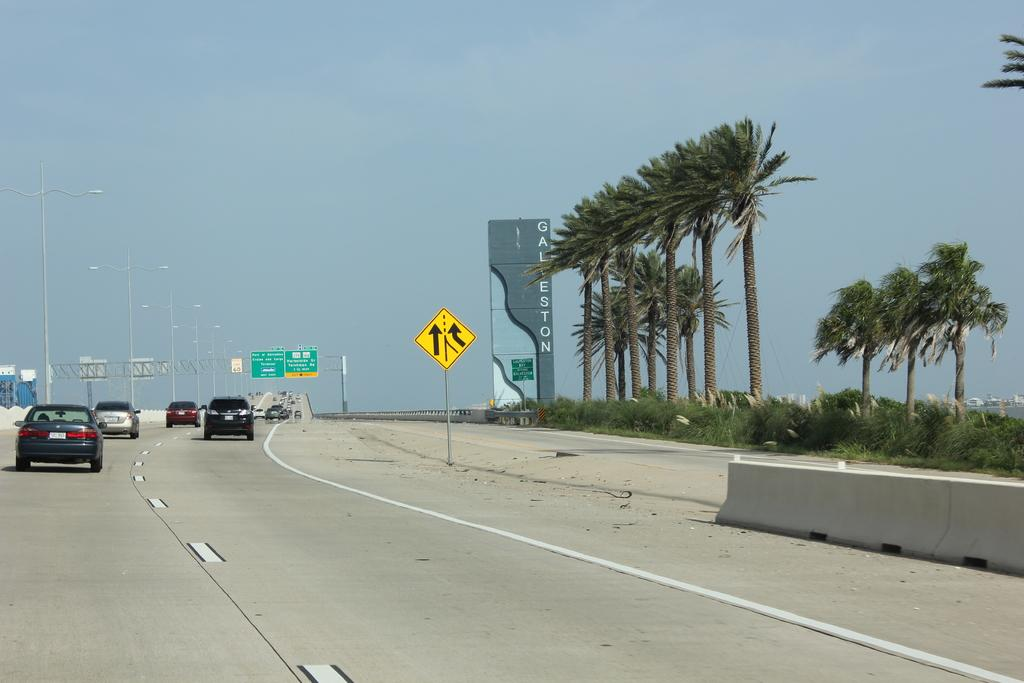What is present on the road in the image? There are vehicles on the road in the image. What can be seen in the left corner of the image? There are light poles in the left corner of the image. What type of vegetation is in the right corner of the image? There are trees in the right corner of the image. Can you tell me how many toothbrushes are hanging from the trees in the image? There are no toothbrushes present in the image; it features vehicles on the road, light poles in the left corner, and trees in the right corner. Is there a basketball game happening in the image? There is no basketball game or any reference to a basketball in the image. 